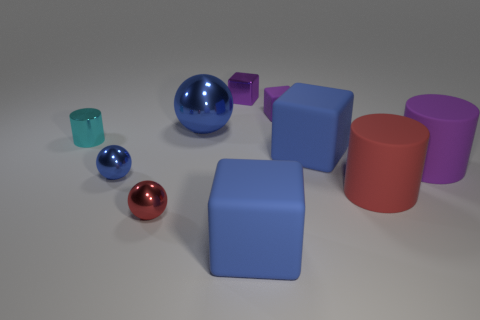What is the material of the cylinder left of the blue object that is behind the tiny cyan shiny cylinder?
Your response must be concise. Metal. Is the shape of the purple metal thing the same as the tiny cyan object?
Your answer should be very brief. No. What color is the metal cube that is the same size as the cyan metallic object?
Keep it short and to the point. Purple. Is there a matte object of the same color as the shiny block?
Offer a terse response. Yes. Are there any tiny cylinders?
Provide a short and direct response. Yes. Do the blue thing that is in front of the small blue shiny sphere and the large red cylinder have the same material?
Ensure brevity in your answer.  Yes. What size is the other ball that is the same color as the big shiny ball?
Ensure brevity in your answer.  Small. How many cyan matte blocks are the same size as the red rubber cylinder?
Provide a short and direct response. 0. Are there an equal number of tiny balls behind the purple matte block and small cyan cylinders?
Offer a very short reply. No. What number of objects are left of the red rubber object and to the right of the purple shiny block?
Ensure brevity in your answer.  3. 